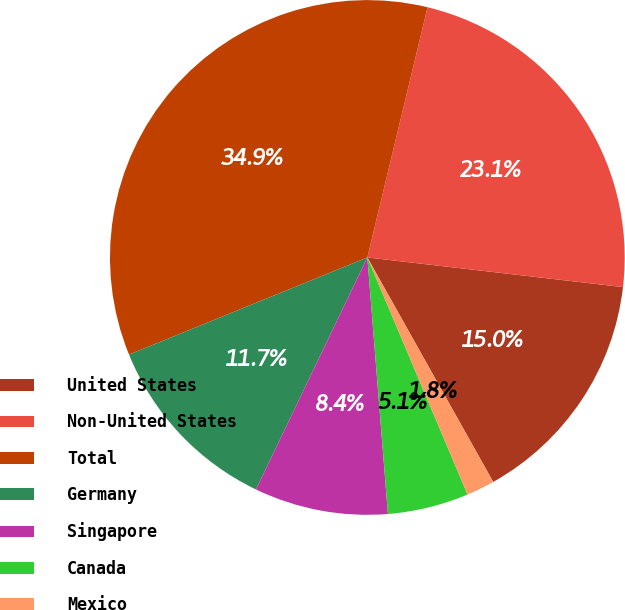Convert chart to OTSL. <chart><loc_0><loc_0><loc_500><loc_500><pie_chart><fcel>United States<fcel>Non-United States<fcel>Total<fcel>Germany<fcel>Singapore<fcel>Canada<fcel>Mexico<nl><fcel>15.03%<fcel>23.08%<fcel>34.92%<fcel>11.72%<fcel>8.4%<fcel>5.09%<fcel>1.77%<nl></chart> 